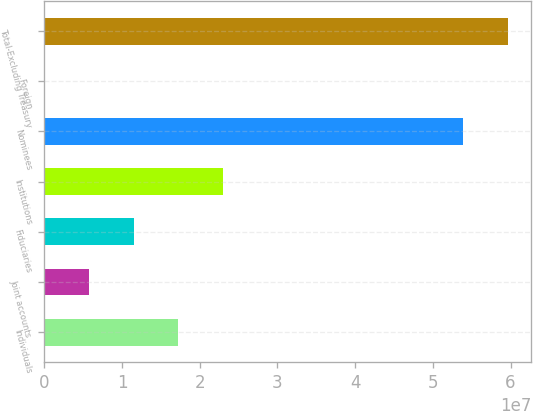Convert chart. <chart><loc_0><loc_0><loc_500><loc_500><bar_chart><fcel>Individuals<fcel>Joint accounts<fcel>Fiduciaries<fcel>Institutions<fcel>Nominees<fcel>Foreign<fcel>Total-Excluding Treasury<nl><fcel>1.72153e+07<fcel>5.7446e+06<fcel>1.14799e+07<fcel>2.29506e+07<fcel>5.39221e+07<fcel>9275<fcel>5.96574e+07<nl></chart> 